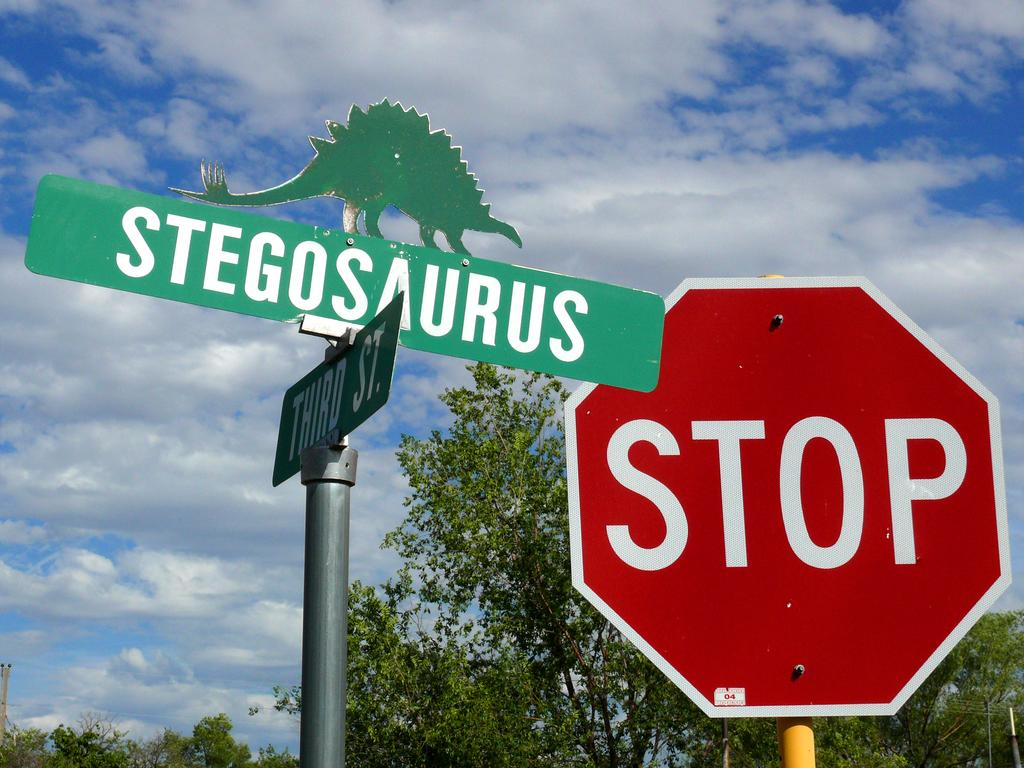What is the main object in the image? There is a signboard in the image. What other objects are related to directions in the image? There are direction boards attached to poles in the image. What can be seen in the background of the image? There are trees and the sky visible in the background of the image. What type of table is placed under the signboard in the image? There is no table present under the signboard in the image. 